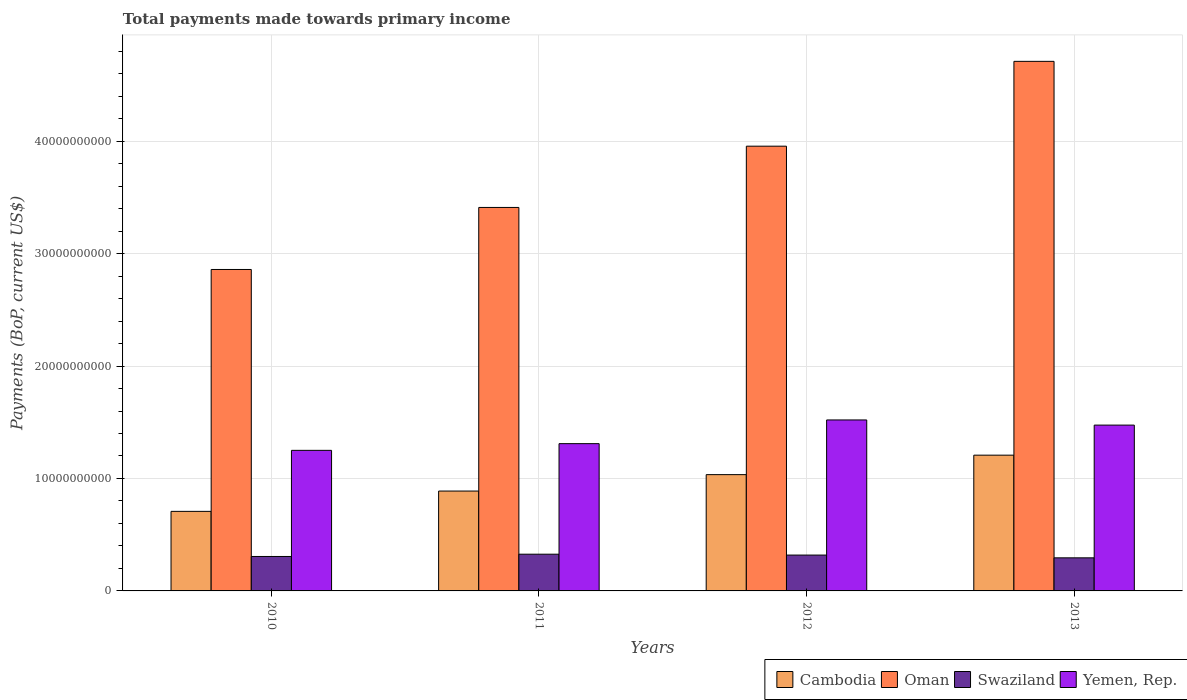How many different coloured bars are there?
Provide a succinct answer. 4. How many groups of bars are there?
Your answer should be very brief. 4. How many bars are there on the 3rd tick from the left?
Provide a short and direct response. 4. How many bars are there on the 2nd tick from the right?
Provide a succinct answer. 4. What is the total payments made towards primary income in Yemen, Rep. in 2013?
Provide a short and direct response. 1.47e+1. Across all years, what is the maximum total payments made towards primary income in Swaziland?
Give a very brief answer. 3.27e+09. Across all years, what is the minimum total payments made towards primary income in Yemen, Rep.?
Offer a very short reply. 1.25e+1. In which year was the total payments made towards primary income in Oman maximum?
Keep it short and to the point. 2013. What is the total total payments made towards primary income in Cambodia in the graph?
Offer a terse response. 3.84e+1. What is the difference between the total payments made towards primary income in Oman in 2011 and that in 2012?
Offer a terse response. -5.45e+09. What is the difference between the total payments made towards primary income in Yemen, Rep. in 2011 and the total payments made towards primary income in Cambodia in 2013?
Your answer should be very brief. 1.02e+09. What is the average total payments made towards primary income in Swaziland per year?
Provide a short and direct response. 3.12e+09. In the year 2013, what is the difference between the total payments made towards primary income in Yemen, Rep. and total payments made towards primary income in Cambodia?
Keep it short and to the point. 2.67e+09. In how many years, is the total payments made towards primary income in Yemen, Rep. greater than 4000000000 US$?
Your response must be concise. 4. What is the ratio of the total payments made towards primary income in Cambodia in 2010 to that in 2012?
Provide a succinct answer. 0.68. Is the total payments made towards primary income in Swaziland in 2010 less than that in 2013?
Your answer should be compact. No. Is the difference between the total payments made towards primary income in Yemen, Rep. in 2010 and 2011 greater than the difference between the total payments made towards primary income in Cambodia in 2010 and 2011?
Make the answer very short. Yes. What is the difference between the highest and the second highest total payments made towards primary income in Swaziland?
Offer a terse response. 7.73e+07. What is the difference between the highest and the lowest total payments made towards primary income in Yemen, Rep.?
Your answer should be very brief. 2.70e+09. In how many years, is the total payments made towards primary income in Swaziland greater than the average total payments made towards primary income in Swaziland taken over all years?
Your response must be concise. 2. What does the 4th bar from the left in 2010 represents?
Offer a terse response. Yemen, Rep. What does the 1st bar from the right in 2013 represents?
Your response must be concise. Yemen, Rep. Is it the case that in every year, the sum of the total payments made towards primary income in Swaziland and total payments made towards primary income in Yemen, Rep. is greater than the total payments made towards primary income in Oman?
Your response must be concise. No. Does the graph contain any zero values?
Offer a terse response. No. Does the graph contain grids?
Give a very brief answer. Yes. Where does the legend appear in the graph?
Your answer should be compact. Bottom right. How many legend labels are there?
Offer a terse response. 4. How are the legend labels stacked?
Provide a succinct answer. Horizontal. What is the title of the graph?
Your response must be concise. Total payments made towards primary income. What is the label or title of the X-axis?
Your response must be concise. Years. What is the label or title of the Y-axis?
Give a very brief answer. Payments (BoP, current US$). What is the Payments (BoP, current US$) of Cambodia in 2010?
Provide a succinct answer. 7.07e+09. What is the Payments (BoP, current US$) of Oman in 2010?
Make the answer very short. 2.86e+1. What is the Payments (BoP, current US$) in Swaziland in 2010?
Offer a very short reply. 3.06e+09. What is the Payments (BoP, current US$) of Yemen, Rep. in 2010?
Offer a terse response. 1.25e+1. What is the Payments (BoP, current US$) in Cambodia in 2011?
Make the answer very short. 8.88e+09. What is the Payments (BoP, current US$) of Oman in 2011?
Your answer should be compact. 3.41e+1. What is the Payments (BoP, current US$) of Swaziland in 2011?
Your answer should be compact. 3.27e+09. What is the Payments (BoP, current US$) of Yemen, Rep. in 2011?
Provide a short and direct response. 1.31e+1. What is the Payments (BoP, current US$) in Cambodia in 2012?
Provide a short and direct response. 1.03e+1. What is the Payments (BoP, current US$) in Oman in 2012?
Keep it short and to the point. 3.96e+1. What is the Payments (BoP, current US$) in Swaziland in 2012?
Your response must be concise. 3.19e+09. What is the Payments (BoP, current US$) of Yemen, Rep. in 2012?
Make the answer very short. 1.52e+1. What is the Payments (BoP, current US$) of Cambodia in 2013?
Your answer should be very brief. 1.21e+1. What is the Payments (BoP, current US$) in Oman in 2013?
Your response must be concise. 4.71e+1. What is the Payments (BoP, current US$) in Swaziland in 2013?
Make the answer very short. 2.94e+09. What is the Payments (BoP, current US$) in Yemen, Rep. in 2013?
Your answer should be compact. 1.47e+1. Across all years, what is the maximum Payments (BoP, current US$) of Cambodia?
Provide a succinct answer. 1.21e+1. Across all years, what is the maximum Payments (BoP, current US$) of Oman?
Provide a short and direct response. 4.71e+1. Across all years, what is the maximum Payments (BoP, current US$) of Swaziland?
Keep it short and to the point. 3.27e+09. Across all years, what is the maximum Payments (BoP, current US$) in Yemen, Rep.?
Ensure brevity in your answer.  1.52e+1. Across all years, what is the minimum Payments (BoP, current US$) of Cambodia?
Make the answer very short. 7.07e+09. Across all years, what is the minimum Payments (BoP, current US$) of Oman?
Ensure brevity in your answer.  2.86e+1. Across all years, what is the minimum Payments (BoP, current US$) of Swaziland?
Offer a terse response. 2.94e+09. Across all years, what is the minimum Payments (BoP, current US$) of Yemen, Rep.?
Your answer should be very brief. 1.25e+1. What is the total Payments (BoP, current US$) of Cambodia in the graph?
Give a very brief answer. 3.84e+1. What is the total Payments (BoP, current US$) of Oman in the graph?
Provide a succinct answer. 1.49e+11. What is the total Payments (BoP, current US$) in Swaziland in the graph?
Your answer should be compact. 1.25e+1. What is the total Payments (BoP, current US$) of Yemen, Rep. in the graph?
Your answer should be compact. 5.56e+1. What is the difference between the Payments (BoP, current US$) in Cambodia in 2010 and that in 2011?
Your answer should be compact. -1.81e+09. What is the difference between the Payments (BoP, current US$) in Oman in 2010 and that in 2011?
Provide a succinct answer. -5.52e+09. What is the difference between the Payments (BoP, current US$) of Swaziland in 2010 and that in 2011?
Provide a short and direct response. -2.02e+08. What is the difference between the Payments (BoP, current US$) in Yemen, Rep. in 2010 and that in 2011?
Provide a short and direct response. -5.96e+08. What is the difference between the Payments (BoP, current US$) in Cambodia in 2010 and that in 2012?
Your response must be concise. -3.27e+09. What is the difference between the Payments (BoP, current US$) of Oman in 2010 and that in 2012?
Provide a succinct answer. -1.10e+1. What is the difference between the Payments (BoP, current US$) of Swaziland in 2010 and that in 2012?
Provide a short and direct response. -1.25e+08. What is the difference between the Payments (BoP, current US$) of Yemen, Rep. in 2010 and that in 2012?
Give a very brief answer. -2.70e+09. What is the difference between the Payments (BoP, current US$) in Cambodia in 2010 and that in 2013?
Your response must be concise. -5.00e+09. What is the difference between the Payments (BoP, current US$) in Oman in 2010 and that in 2013?
Keep it short and to the point. -1.85e+1. What is the difference between the Payments (BoP, current US$) of Swaziland in 2010 and that in 2013?
Keep it short and to the point. 1.20e+08. What is the difference between the Payments (BoP, current US$) in Yemen, Rep. in 2010 and that in 2013?
Provide a succinct answer. -2.24e+09. What is the difference between the Payments (BoP, current US$) of Cambodia in 2011 and that in 2012?
Offer a terse response. -1.46e+09. What is the difference between the Payments (BoP, current US$) in Oman in 2011 and that in 2012?
Make the answer very short. -5.45e+09. What is the difference between the Payments (BoP, current US$) in Swaziland in 2011 and that in 2012?
Offer a very short reply. 7.73e+07. What is the difference between the Payments (BoP, current US$) in Yemen, Rep. in 2011 and that in 2012?
Give a very brief answer. -2.11e+09. What is the difference between the Payments (BoP, current US$) of Cambodia in 2011 and that in 2013?
Provide a short and direct response. -3.19e+09. What is the difference between the Payments (BoP, current US$) in Oman in 2011 and that in 2013?
Give a very brief answer. -1.30e+1. What is the difference between the Payments (BoP, current US$) in Swaziland in 2011 and that in 2013?
Give a very brief answer. 3.23e+08. What is the difference between the Payments (BoP, current US$) of Yemen, Rep. in 2011 and that in 2013?
Your response must be concise. -1.65e+09. What is the difference between the Payments (BoP, current US$) in Cambodia in 2012 and that in 2013?
Make the answer very short. -1.73e+09. What is the difference between the Payments (BoP, current US$) of Oman in 2012 and that in 2013?
Keep it short and to the point. -7.54e+09. What is the difference between the Payments (BoP, current US$) in Swaziland in 2012 and that in 2013?
Give a very brief answer. 2.46e+08. What is the difference between the Payments (BoP, current US$) in Yemen, Rep. in 2012 and that in 2013?
Offer a terse response. 4.59e+08. What is the difference between the Payments (BoP, current US$) in Cambodia in 2010 and the Payments (BoP, current US$) in Oman in 2011?
Offer a very short reply. -2.70e+1. What is the difference between the Payments (BoP, current US$) in Cambodia in 2010 and the Payments (BoP, current US$) in Swaziland in 2011?
Make the answer very short. 3.81e+09. What is the difference between the Payments (BoP, current US$) of Cambodia in 2010 and the Payments (BoP, current US$) of Yemen, Rep. in 2011?
Ensure brevity in your answer.  -6.02e+09. What is the difference between the Payments (BoP, current US$) of Oman in 2010 and the Payments (BoP, current US$) of Swaziland in 2011?
Keep it short and to the point. 2.53e+1. What is the difference between the Payments (BoP, current US$) in Oman in 2010 and the Payments (BoP, current US$) in Yemen, Rep. in 2011?
Provide a short and direct response. 1.55e+1. What is the difference between the Payments (BoP, current US$) in Swaziland in 2010 and the Payments (BoP, current US$) in Yemen, Rep. in 2011?
Your response must be concise. -1.00e+1. What is the difference between the Payments (BoP, current US$) of Cambodia in 2010 and the Payments (BoP, current US$) of Oman in 2012?
Provide a short and direct response. -3.25e+1. What is the difference between the Payments (BoP, current US$) in Cambodia in 2010 and the Payments (BoP, current US$) in Swaziland in 2012?
Keep it short and to the point. 3.89e+09. What is the difference between the Payments (BoP, current US$) in Cambodia in 2010 and the Payments (BoP, current US$) in Yemen, Rep. in 2012?
Keep it short and to the point. -8.13e+09. What is the difference between the Payments (BoP, current US$) in Oman in 2010 and the Payments (BoP, current US$) in Swaziland in 2012?
Provide a succinct answer. 2.54e+1. What is the difference between the Payments (BoP, current US$) in Oman in 2010 and the Payments (BoP, current US$) in Yemen, Rep. in 2012?
Offer a very short reply. 1.34e+1. What is the difference between the Payments (BoP, current US$) of Swaziland in 2010 and the Payments (BoP, current US$) of Yemen, Rep. in 2012?
Your response must be concise. -1.21e+1. What is the difference between the Payments (BoP, current US$) in Cambodia in 2010 and the Payments (BoP, current US$) in Oman in 2013?
Give a very brief answer. -4.00e+1. What is the difference between the Payments (BoP, current US$) of Cambodia in 2010 and the Payments (BoP, current US$) of Swaziland in 2013?
Provide a succinct answer. 4.13e+09. What is the difference between the Payments (BoP, current US$) of Cambodia in 2010 and the Payments (BoP, current US$) of Yemen, Rep. in 2013?
Ensure brevity in your answer.  -7.67e+09. What is the difference between the Payments (BoP, current US$) of Oman in 2010 and the Payments (BoP, current US$) of Swaziland in 2013?
Make the answer very short. 2.56e+1. What is the difference between the Payments (BoP, current US$) in Oman in 2010 and the Payments (BoP, current US$) in Yemen, Rep. in 2013?
Make the answer very short. 1.38e+1. What is the difference between the Payments (BoP, current US$) of Swaziland in 2010 and the Payments (BoP, current US$) of Yemen, Rep. in 2013?
Provide a succinct answer. -1.17e+1. What is the difference between the Payments (BoP, current US$) of Cambodia in 2011 and the Payments (BoP, current US$) of Oman in 2012?
Provide a succinct answer. -3.07e+1. What is the difference between the Payments (BoP, current US$) of Cambodia in 2011 and the Payments (BoP, current US$) of Swaziland in 2012?
Offer a terse response. 5.69e+09. What is the difference between the Payments (BoP, current US$) in Cambodia in 2011 and the Payments (BoP, current US$) in Yemen, Rep. in 2012?
Your answer should be compact. -6.32e+09. What is the difference between the Payments (BoP, current US$) of Oman in 2011 and the Payments (BoP, current US$) of Swaziland in 2012?
Offer a terse response. 3.09e+1. What is the difference between the Payments (BoP, current US$) of Oman in 2011 and the Payments (BoP, current US$) of Yemen, Rep. in 2012?
Offer a very short reply. 1.89e+1. What is the difference between the Payments (BoP, current US$) of Swaziland in 2011 and the Payments (BoP, current US$) of Yemen, Rep. in 2012?
Make the answer very short. -1.19e+1. What is the difference between the Payments (BoP, current US$) in Cambodia in 2011 and the Payments (BoP, current US$) in Oman in 2013?
Offer a terse response. -3.82e+1. What is the difference between the Payments (BoP, current US$) of Cambodia in 2011 and the Payments (BoP, current US$) of Swaziland in 2013?
Offer a terse response. 5.94e+09. What is the difference between the Payments (BoP, current US$) in Cambodia in 2011 and the Payments (BoP, current US$) in Yemen, Rep. in 2013?
Provide a succinct answer. -5.87e+09. What is the difference between the Payments (BoP, current US$) of Oman in 2011 and the Payments (BoP, current US$) of Swaziland in 2013?
Your answer should be compact. 3.12e+1. What is the difference between the Payments (BoP, current US$) in Oman in 2011 and the Payments (BoP, current US$) in Yemen, Rep. in 2013?
Give a very brief answer. 1.94e+1. What is the difference between the Payments (BoP, current US$) of Swaziland in 2011 and the Payments (BoP, current US$) of Yemen, Rep. in 2013?
Your response must be concise. -1.15e+1. What is the difference between the Payments (BoP, current US$) in Cambodia in 2012 and the Payments (BoP, current US$) in Oman in 2013?
Provide a short and direct response. -3.68e+1. What is the difference between the Payments (BoP, current US$) in Cambodia in 2012 and the Payments (BoP, current US$) in Swaziland in 2013?
Provide a succinct answer. 7.40e+09. What is the difference between the Payments (BoP, current US$) in Cambodia in 2012 and the Payments (BoP, current US$) in Yemen, Rep. in 2013?
Make the answer very short. -4.40e+09. What is the difference between the Payments (BoP, current US$) of Oman in 2012 and the Payments (BoP, current US$) of Swaziland in 2013?
Keep it short and to the point. 3.66e+1. What is the difference between the Payments (BoP, current US$) in Oman in 2012 and the Payments (BoP, current US$) in Yemen, Rep. in 2013?
Ensure brevity in your answer.  2.48e+1. What is the difference between the Payments (BoP, current US$) in Swaziland in 2012 and the Payments (BoP, current US$) in Yemen, Rep. in 2013?
Your response must be concise. -1.16e+1. What is the average Payments (BoP, current US$) of Cambodia per year?
Keep it short and to the point. 9.59e+09. What is the average Payments (BoP, current US$) of Oman per year?
Your response must be concise. 3.73e+1. What is the average Payments (BoP, current US$) in Swaziland per year?
Offer a terse response. 3.12e+09. What is the average Payments (BoP, current US$) in Yemen, Rep. per year?
Offer a very short reply. 1.39e+1. In the year 2010, what is the difference between the Payments (BoP, current US$) in Cambodia and Payments (BoP, current US$) in Oman?
Provide a short and direct response. -2.15e+1. In the year 2010, what is the difference between the Payments (BoP, current US$) in Cambodia and Payments (BoP, current US$) in Swaziland?
Ensure brevity in your answer.  4.01e+09. In the year 2010, what is the difference between the Payments (BoP, current US$) of Cambodia and Payments (BoP, current US$) of Yemen, Rep.?
Make the answer very short. -5.43e+09. In the year 2010, what is the difference between the Payments (BoP, current US$) of Oman and Payments (BoP, current US$) of Swaziland?
Ensure brevity in your answer.  2.55e+1. In the year 2010, what is the difference between the Payments (BoP, current US$) in Oman and Payments (BoP, current US$) in Yemen, Rep.?
Make the answer very short. 1.61e+1. In the year 2010, what is the difference between the Payments (BoP, current US$) of Swaziland and Payments (BoP, current US$) of Yemen, Rep.?
Give a very brief answer. -9.44e+09. In the year 2011, what is the difference between the Payments (BoP, current US$) of Cambodia and Payments (BoP, current US$) of Oman?
Provide a succinct answer. -2.52e+1. In the year 2011, what is the difference between the Payments (BoP, current US$) of Cambodia and Payments (BoP, current US$) of Swaziland?
Ensure brevity in your answer.  5.62e+09. In the year 2011, what is the difference between the Payments (BoP, current US$) in Cambodia and Payments (BoP, current US$) in Yemen, Rep.?
Offer a terse response. -4.22e+09. In the year 2011, what is the difference between the Payments (BoP, current US$) in Oman and Payments (BoP, current US$) in Swaziland?
Provide a succinct answer. 3.08e+1. In the year 2011, what is the difference between the Payments (BoP, current US$) of Oman and Payments (BoP, current US$) of Yemen, Rep.?
Keep it short and to the point. 2.10e+1. In the year 2011, what is the difference between the Payments (BoP, current US$) in Swaziland and Payments (BoP, current US$) in Yemen, Rep.?
Keep it short and to the point. -9.83e+09. In the year 2012, what is the difference between the Payments (BoP, current US$) of Cambodia and Payments (BoP, current US$) of Oman?
Offer a very short reply. -2.92e+1. In the year 2012, what is the difference between the Payments (BoP, current US$) of Cambodia and Payments (BoP, current US$) of Swaziland?
Offer a very short reply. 7.15e+09. In the year 2012, what is the difference between the Payments (BoP, current US$) in Cambodia and Payments (BoP, current US$) in Yemen, Rep.?
Offer a terse response. -4.86e+09. In the year 2012, what is the difference between the Payments (BoP, current US$) in Oman and Payments (BoP, current US$) in Swaziland?
Provide a succinct answer. 3.64e+1. In the year 2012, what is the difference between the Payments (BoP, current US$) of Oman and Payments (BoP, current US$) of Yemen, Rep.?
Your answer should be compact. 2.43e+1. In the year 2012, what is the difference between the Payments (BoP, current US$) in Swaziland and Payments (BoP, current US$) in Yemen, Rep.?
Make the answer very short. -1.20e+1. In the year 2013, what is the difference between the Payments (BoP, current US$) in Cambodia and Payments (BoP, current US$) in Oman?
Your answer should be very brief. -3.50e+1. In the year 2013, what is the difference between the Payments (BoP, current US$) of Cambodia and Payments (BoP, current US$) of Swaziland?
Offer a very short reply. 9.13e+09. In the year 2013, what is the difference between the Payments (BoP, current US$) in Cambodia and Payments (BoP, current US$) in Yemen, Rep.?
Offer a terse response. -2.67e+09. In the year 2013, what is the difference between the Payments (BoP, current US$) of Oman and Payments (BoP, current US$) of Swaziland?
Your answer should be very brief. 4.42e+1. In the year 2013, what is the difference between the Payments (BoP, current US$) of Oman and Payments (BoP, current US$) of Yemen, Rep.?
Ensure brevity in your answer.  3.24e+1. In the year 2013, what is the difference between the Payments (BoP, current US$) in Swaziland and Payments (BoP, current US$) in Yemen, Rep.?
Make the answer very short. -1.18e+1. What is the ratio of the Payments (BoP, current US$) in Cambodia in 2010 to that in 2011?
Your answer should be very brief. 0.8. What is the ratio of the Payments (BoP, current US$) in Oman in 2010 to that in 2011?
Offer a terse response. 0.84. What is the ratio of the Payments (BoP, current US$) in Swaziland in 2010 to that in 2011?
Ensure brevity in your answer.  0.94. What is the ratio of the Payments (BoP, current US$) of Yemen, Rep. in 2010 to that in 2011?
Offer a terse response. 0.95. What is the ratio of the Payments (BoP, current US$) of Cambodia in 2010 to that in 2012?
Your response must be concise. 0.68. What is the ratio of the Payments (BoP, current US$) in Oman in 2010 to that in 2012?
Offer a terse response. 0.72. What is the ratio of the Payments (BoP, current US$) of Swaziland in 2010 to that in 2012?
Your answer should be very brief. 0.96. What is the ratio of the Payments (BoP, current US$) in Yemen, Rep. in 2010 to that in 2012?
Your response must be concise. 0.82. What is the ratio of the Payments (BoP, current US$) of Cambodia in 2010 to that in 2013?
Your response must be concise. 0.59. What is the ratio of the Payments (BoP, current US$) of Oman in 2010 to that in 2013?
Offer a terse response. 0.61. What is the ratio of the Payments (BoP, current US$) in Swaziland in 2010 to that in 2013?
Make the answer very short. 1.04. What is the ratio of the Payments (BoP, current US$) in Yemen, Rep. in 2010 to that in 2013?
Your answer should be very brief. 0.85. What is the ratio of the Payments (BoP, current US$) in Cambodia in 2011 to that in 2012?
Ensure brevity in your answer.  0.86. What is the ratio of the Payments (BoP, current US$) in Oman in 2011 to that in 2012?
Offer a terse response. 0.86. What is the ratio of the Payments (BoP, current US$) of Swaziland in 2011 to that in 2012?
Ensure brevity in your answer.  1.02. What is the ratio of the Payments (BoP, current US$) of Yemen, Rep. in 2011 to that in 2012?
Give a very brief answer. 0.86. What is the ratio of the Payments (BoP, current US$) of Cambodia in 2011 to that in 2013?
Your answer should be compact. 0.74. What is the ratio of the Payments (BoP, current US$) of Oman in 2011 to that in 2013?
Give a very brief answer. 0.72. What is the ratio of the Payments (BoP, current US$) in Swaziland in 2011 to that in 2013?
Offer a very short reply. 1.11. What is the ratio of the Payments (BoP, current US$) of Yemen, Rep. in 2011 to that in 2013?
Provide a short and direct response. 0.89. What is the ratio of the Payments (BoP, current US$) of Cambodia in 2012 to that in 2013?
Your answer should be compact. 0.86. What is the ratio of the Payments (BoP, current US$) of Oman in 2012 to that in 2013?
Make the answer very short. 0.84. What is the ratio of the Payments (BoP, current US$) in Swaziland in 2012 to that in 2013?
Provide a short and direct response. 1.08. What is the ratio of the Payments (BoP, current US$) of Yemen, Rep. in 2012 to that in 2013?
Ensure brevity in your answer.  1.03. What is the difference between the highest and the second highest Payments (BoP, current US$) in Cambodia?
Keep it short and to the point. 1.73e+09. What is the difference between the highest and the second highest Payments (BoP, current US$) of Oman?
Make the answer very short. 7.54e+09. What is the difference between the highest and the second highest Payments (BoP, current US$) of Swaziland?
Your answer should be very brief. 7.73e+07. What is the difference between the highest and the second highest Payments (BoP, current US$) in Yemen, Rep.?
Your answer should be compact. 4.59e+08. What is the difference between the highest and the lowest Payments (BoP, current US$) of Cambodia?
Your answer should be very brief. 5.00e+09. What is the difference between the highest and the lowest Payments (BoP, current US$) of Oman?
Offer a very short reply. 1.85e+1. What is the difference between the highest and the lowest Payments (BoP, current US$) of Swaziland?
Offer a terse response. 3.23e+08. What is the difference between the highest and the lowest Payments (BoP, current US$) in Yemen, Rep.?
Offer a terse response. 2.70e+09. 